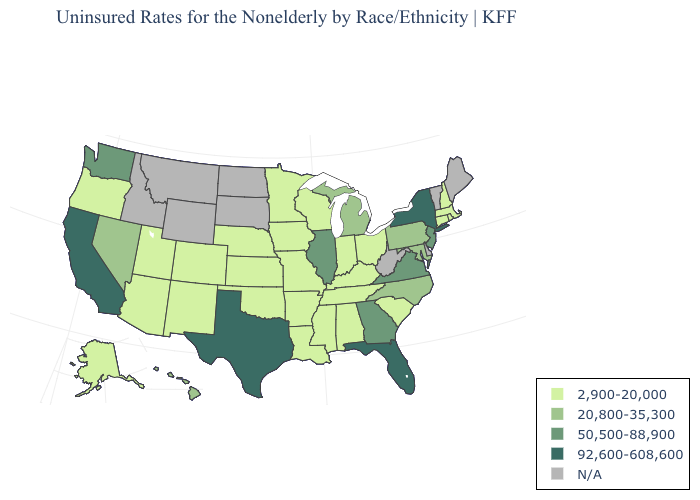Does Illinois have the highest value in the MidWest?
Be succinct. Yes. Among the states that border Delaware , does New Jersey have the lowest value?
Concise answer only. No. Does Maryland have the lowest value in the USA?
Quick response, please. No. Among the states that border West Virginia , does Ohio have the highest value?
Be succinct. No. Which states hav the highest value in the Northeast?
Write a very short answer. New York. What is the value of Rhode Island?
Short answer required. 2,900-20,000. What is the highest value in the USA?
Keep it brief. 92,600-608,600. Is the legend a continuous bar?
Give a very brief answer. No. What is the highest value in the South ?
Be succinct. 92,600-608,600. What is the value of New York?
Be succinct. 92,600-608,600. What is the value of Kentucky?
Answer briefly. 2,900-20,000. Does Virginia have the highest value in the South?
Quick response, please. No. What is the lowest value in the USA?
Write a very short answer. 2,900-20,000. Name the states that have a value in the range 2,900-20,000?
Give a very brief answer. Alabama, Alaska, Arizona, Arkansas, Colorado, Connecticut, Indiana, Iowa, Kansas, Kentucky, Louisiana, Massachusetts, Minnesota, Mississippi, Missouri, Nebraska, New Hampshire, New Mexico, Ohio, Oklahoma, Oregon, Rhode Island, South Carolina, Tennessee, Utah, Wisconsin. 